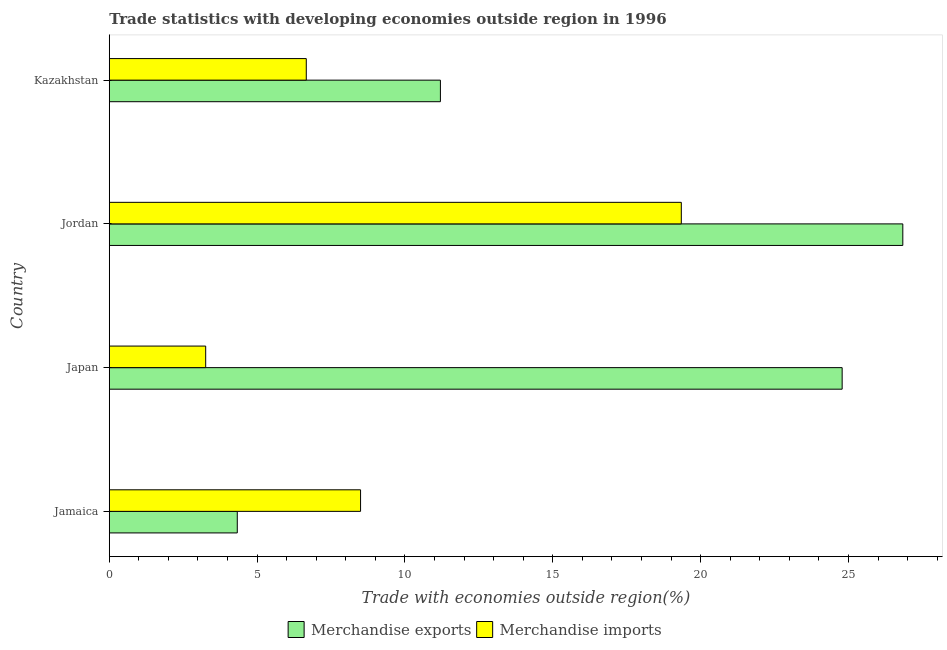How many different coloured bars are there?
Keep it short and to the point. 2. How many groups of bars are there?
Make the answer very short. 4. Are the number of bars on each tick of the Y-axis equal?
Make the answer very short. Yes. How many bars are there on the 3rd tick from the top?
Provide a succinct answer. 2. What is the label of the 3rd group of bars from the top?
Your answer should be very brief. Japan. What is the merchandise exports in Jamaica?
Offer a terse response. 4.33. Across all countries, what is the maximum merchandise imports?
Provide a succinct answer. 19.35. Across all countries, what is the minimum merchandise exports?
Ensure brevity in your answer.  4.33. In which country was the merchandise exports maximum?
Offer a terse response. Jordan. In which country was the merchandise imports minimum?
Give a very brief answer. Japan. What is the total merchandise exports in the graph?
Give a very brief answer. 67.15. What is the difference between the merchandise imports in Jamaica and that in Kazakhstan?
Keep it short and to the point. 1.84. What is the difference between the merchandise exports in Kazakhstan and the merchandise imports in Jordan?
Provide a succinct answer. -8.15. What is the average merchandise imports per country?
Make the answer very short. 9.44. What is the difference between the merchandise imports and merchandise exports in Japan?
Offer a terse response. -21.53. What is the ratio of the merchandise exports in Jordan to that in Kazakhstan?
Your response must be concise. 2.4. Is the merchandise exports in Jordan less than that in Kazakhstan?
Ensure brevity in your answer.  No. What is the difference between the highest and the second highest merchandise exports?
Provide a short and direct response. 2.05. What is the difference between the highest and the lowest merchandise exports?
Provide a short and direct response. 22.51. In how many countries, is the merchandise imports greater than the average merchandise imports taken over all countries?
Give a very brief answer. 1. What does the 2nd bar from the top in Kazakhstan represents?
Provide a succinct answer. Merchandise exports. Are all the bars in the graph horizontal?
Offer a very short reply. Yes. Does the graph contain grids?
Your answer should be compact. No. How many legend labels are there?
Ensure brevity in your answer.  2. What is the title of the graph?
Offer a terse response. Trade statistics with developing economies outside region in 1996. What is the label or title of the X-axis?
Ensure brevity in your answer.  Trade with economies outside region(%). What is the Trade with economies outside region(%) in Merchandise exports in Jamaica?
Your response must be concise. 4.33. What is the Trade with economies outside region(%) in Merchandise imports in Jamaica?
Provide a short and direct response. 8.5. What is the Trade with economies outside region(%) in Merchandise exports in Japan?
Your answer should be compact. 24.79. What is the Trade with economies outside region(%) in Merchandise imports in Japan?
Your answer should be very brief. 3.26. What is the Trade with economies outside region(%) of Merchandise exports in Jordan?
Provide a succinct answer. 26.84. What is the Trade with economies outside region(%) of Merchandise imports in Jordan?
Provide a succinct answer. 19.35. What is the Trade with economies outside region(%) of Merchandise exports in Kazakhstan?
Give a very brief answer. 11.2. What is the Trade with economies outside region(%) in Merchandise imports in Kazakhstan?
Offer a terse response. 6.66. Across all countries, what is the maximum Trade with economies outside region(%) in Merchandise exports?
Provide a short and direct response. 26.84. Across all countries, what is the maximum Trade with economies outside region(%) of Merchandise imports?
Your answer should be compact. 19.35. Across all countries, what is the minimum Trade with economies outside region(%) of Merchandise exports?
Provide a short and direct response. 4.33. Across all countries, what is the minimum Trade with economies outside region(%) in Merchandise imports?
Your answer should be compact. 3.26. What is the total Trade with economies outside region(%) of Merchandise exports in the graph?
Offer a terse response. 67.15. What is the total Trade with economies outside region(%) of Merchandise imports in the graph?
Ensure brevity in your answer.  37.77. What is the difference between the Trade with economies outside region(%) in Merchandise exports in Jamaica and that in Japan?
Provide a short and direct response. -20.46. What is the difference between the Trade with economies outside region(%) of Merchandise imports in Jamaica and that in Japan?
Your response must be concise. 5.24. What is the difference between the Trade with economies outside region(%) in Merchandise exports in Jamaica and that in Jordan?
Keep it short and to the point. -22.51. What is the difference between the Trade with economies outside region(%) of Merchandise imports in Jamaica and that in Jordan?
Give a very brief answer. -10.85. What is the difference between the Trade with economies outside region(%) in Merchandise exports in Jamaica and that in Kazakhstan?
Make the answer very short. -6.87. What is the difference between the Trade with economies outside region(%) in Merchandise imports in Jamaica and that in Kazakhstan?
Make the answer very short. 1.84. What is the difference between the Trade with economies outside region(%) of Merchandise exports in Japan and that in Jordan?
Your answer should be very brief. -2.05. What is the difference between the Trade with economies outside region(%) of Merchandise imports in Japan and that in Jordan?
Your answer should be very brief. -16.09. What is the difference between the Trade with economies outside region(%) in Merchandise exports in Japan and that in Kazakhstan?
Provide a succinct answer. 13.59. What is the difference between the Trade with economies outside region(%) in Merchandise imports in Japan and that in Kazakhstan?
Offer a very short reply. -3.4. What is the difference between the Trade with economies outside region(%) of Merchandise exports in Jordan and that in Kazakhstan?
Offer a very short reply. 15.64. What is the difference between the Trade with economies outside region(%) of Merchandise imports in Jordan and that in Kazakhstan?
Provide a succinct answer. 12.68. What is the difference between the Trade with economies outside region(%) of Merchandise exports in Jamaica and the Trade with economies outside region(%) of Merchandise imports in Japan?
Your response must be concise. 1.07. What is the difference between the Trade with economies outside region(%) of Merchandise exports in Jamaica and the Trade with economies outside region(%) of Merchandise imports in Jordan?
Provide a succinct answer. -15.02. What is the difference between the Trade with economies outside region(%) of Merchandise exports in Jamaica and the Trade with economies outside region(%) of Merchandise imports in Kazakhstan?
Ensure brevity in your answer.  -2.33. What is the difference between the Trade with economies outside region(%) in Merchandise exports in Japan and the Trade with economies outside region(%) in Merchandise imports in Jordan?
Your answer should be very brief. 5.44. What is the difference between the Trade with economies outside region(%) in Merchandise exports in Japan and the Trade with economies outside region(%) in Merchandise imports in Kazakhstan?
Keep it short and to the point. 18.12. What is the difference between the Trade with economies outside region(%) in Merchandise exports in Jordan and the Trade with economies outside region(%) in Merchandise imports in Kazakhstan?
Your answer should be compact. 20.18. What is the average Trade with economies outside region(%) in Merchandise exports per country?
Give a very brief answer. 16.79. What is the average Trade with economies outside region(%) in Merchandise imports per country?
Your answer should be compact. 9.44. What is the difference between the Trade with economies outside region(%) of Merchandise exports and Trade with economies outside region(%) of Merchandise imports in Jamaica?
Ensure brevity in your answer.  -4.17. What is the difference between the Trade with economies outside region(%) of Merchandise exports and Trade with economies outside region(%) of Merchandise imports in Japan?
Ensure brevity in your answer.  21.53. What is the difference between the Trade with economies outside region(%) in Merchandise exports and Trade with economies outside region(%) in Merchandise imports in Jordan?
Provide a succinct answer. 7.49. What is the difference between the Trade with economies outside region(%) in Merchandise exports and Trade with economies outside region(%) in Merchandise imports in Kazakhstan?
Your answer should be compact. 4.54. What is the ratio of the Trade with economies outside region(%) in Merchandise exports in Jamaica to that in Japan?
Keep it short and to the point. 0.17. What is the ratio of the Trade with economies outside region(%) in Merchandise imports in Jamaica to that in Japan?
Offer a terse response. 2.61. What is the ratio of the Trade with economies outside region(%) of Merchandise exports in Jamaica to that in Jordan?
Make the answer very short. 0.16. What is the ratio of the Trade with economies outside region(%) of Merchandise imports in Jamaica to that in Jordan?
Give a very brief answer. 0.44. What is the ratio of the Trade with economies outside region(%) in Merchandise exports in Jamaica to that in Kazakhstan?
Offer a terse response. 0.39. What is the ratio of the Trade with economies outside region(%) in Merchandise imports in Jamaica to that in Kazakhstan?
Offer a terse response. 1.28. What is the ratio of the Trade with economies outside region(%) in Merchandise exports in Japan to that in Jordan?
Your answer should be compact. 0.92. What is the ratio of the Trade with economies outside region(%) in Merchandise imports in Japan to that in Jordan?
Provide a short and direct response. 0.17. What is the ratio of the Trade with economies outside region(%) in Merchandise exports in Japan to that in Kazakhstan?
Make the answer very short. 2.21. What is the ratio of the Trade with economies outside region(%) in Merchandise imports in Japan to that in Kazakhstan?
Keep it short and to the point. 0.49. What is the ratio of the Trade with economies outside region(%) in Merchandise exports in Jordan to that in Kazakhstan?
Offer a very short reply. 2.4. What is the ratio of the Trade with economies outside region(%) in Merchandise imports in Jordan to that in Kazakhstan?
Your answer should be very brief. 2.9. What is the difference between the highest and the second highest Trade with economies outside region(%) of Merchandise exports?
Your answer should be very brief. 2.05. What is the difference between the highest and the second highest Trade with economies outside region(%) of Merchandise imports?
Your answer should be compact. 10.85. What is the difference between the highest and the lowest Trade with economies outside region(%) in Merchandise exports?
Keep it short and to the point. 22.51. What is the difference between the highest and the lowest Trade with economies outside region(%) in Merchandise imports?
Keep it short and to the point. 16.09. 